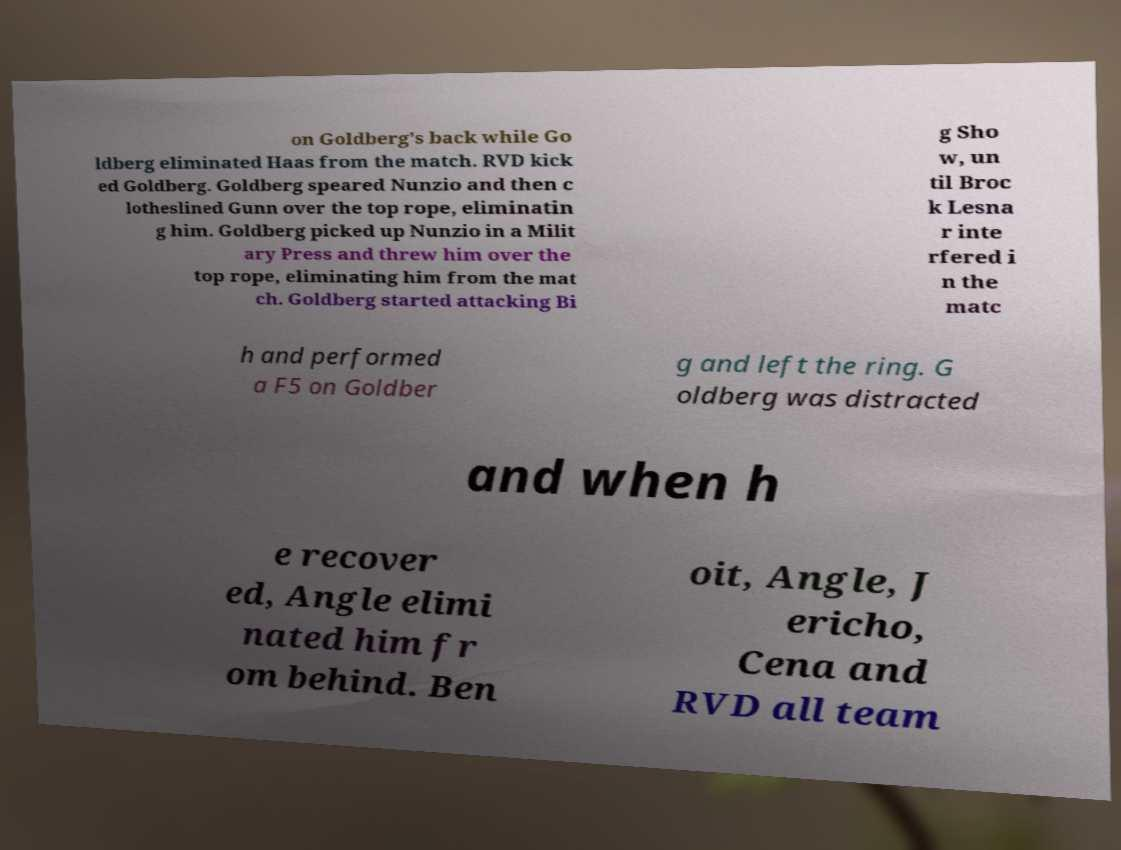For documentation purposes, I need the text within this image transcribed. Could you provide that? on Goldberg's back while Go ldberg eliminated Haas from the match. RVD kick ed Goldberg. Goldberg speared Nunzio and then c lotheslined Gunn over the top rope, eliminatin g him. Goldberg picked up Nunzio in a Milit ary Press and threw him over the top rope, eliminating him from the mat ch. Goldberg started attacking Bi g Sho w, un til Broc k Lesna r inte rfered i n the matc h and performed a F5 on Goldber g and left the ring. G oldberg was distracted and when h e recover ed, Angle elimi nated him fr om behind. Ben oit, Angle, J ericho, Cena and RVD all team 